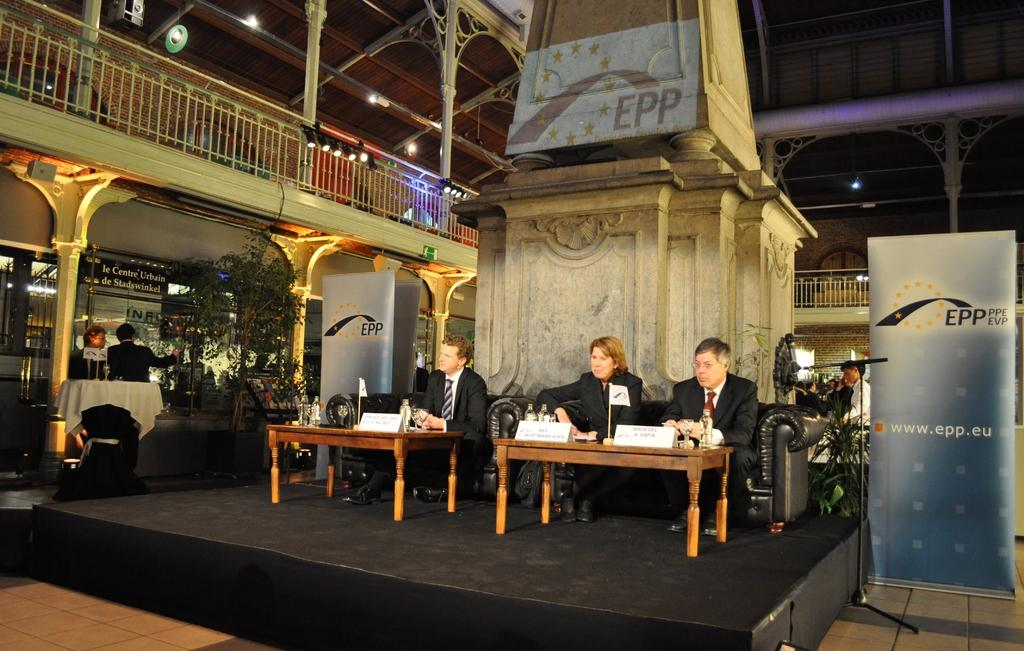How many people are in the image? There are two men and a woman in the image, making a total of three people. What are they doing in the image? They are sitting on a sofa. Can you describe the setting of the image? The scene is on a stage, and there are people around them. How many tables are visible in the image? There are two tables in the image. What type of lace is used to decorate the beds in the image? There are no beds present in the image, so there is no lace to be found. 